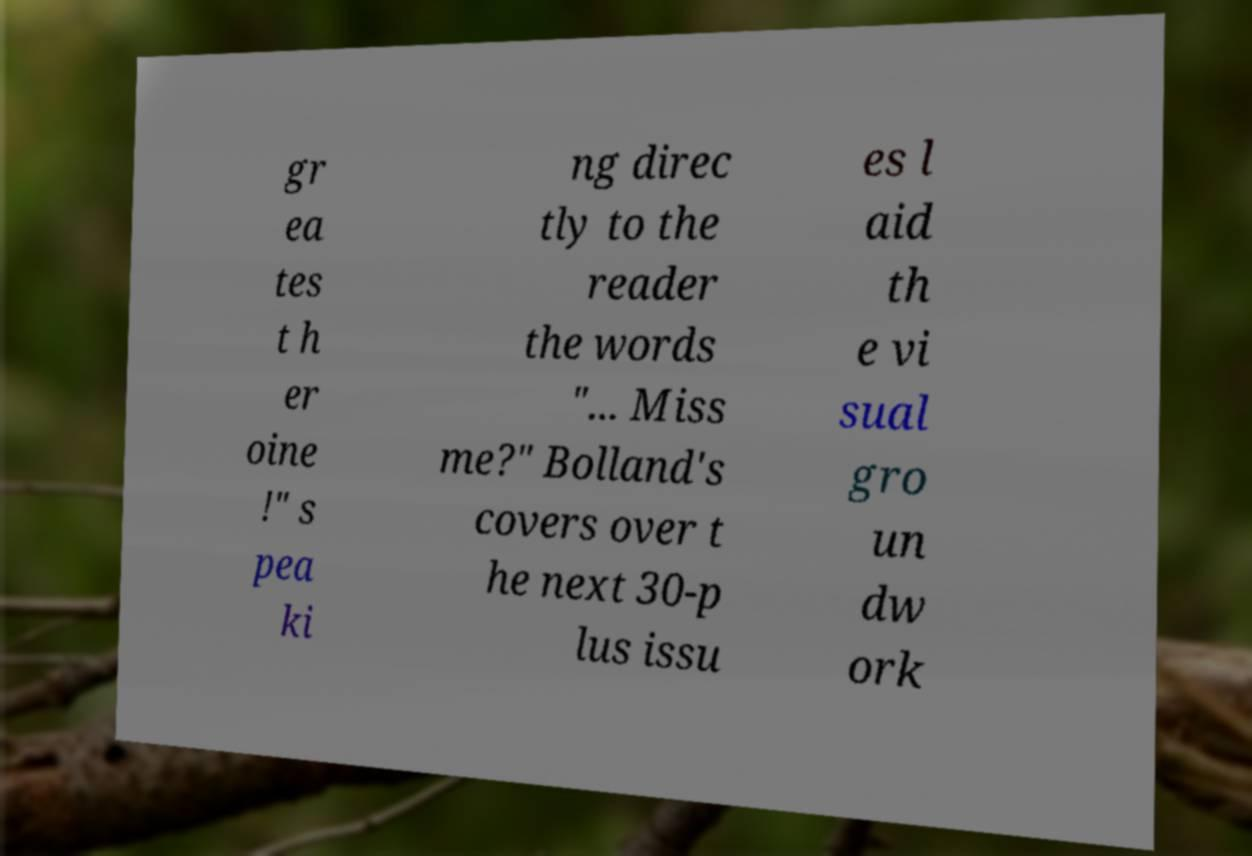There's text embedded in this image that I need extracted. Can you transcribe it verbatim? gr ea tes t h er oine !" s pea ki ng direc tly to the reader the words "... Miss me?" Bolland's covers over t he next 30-p lus issu es l aid th e vi sual gro un dw ork 